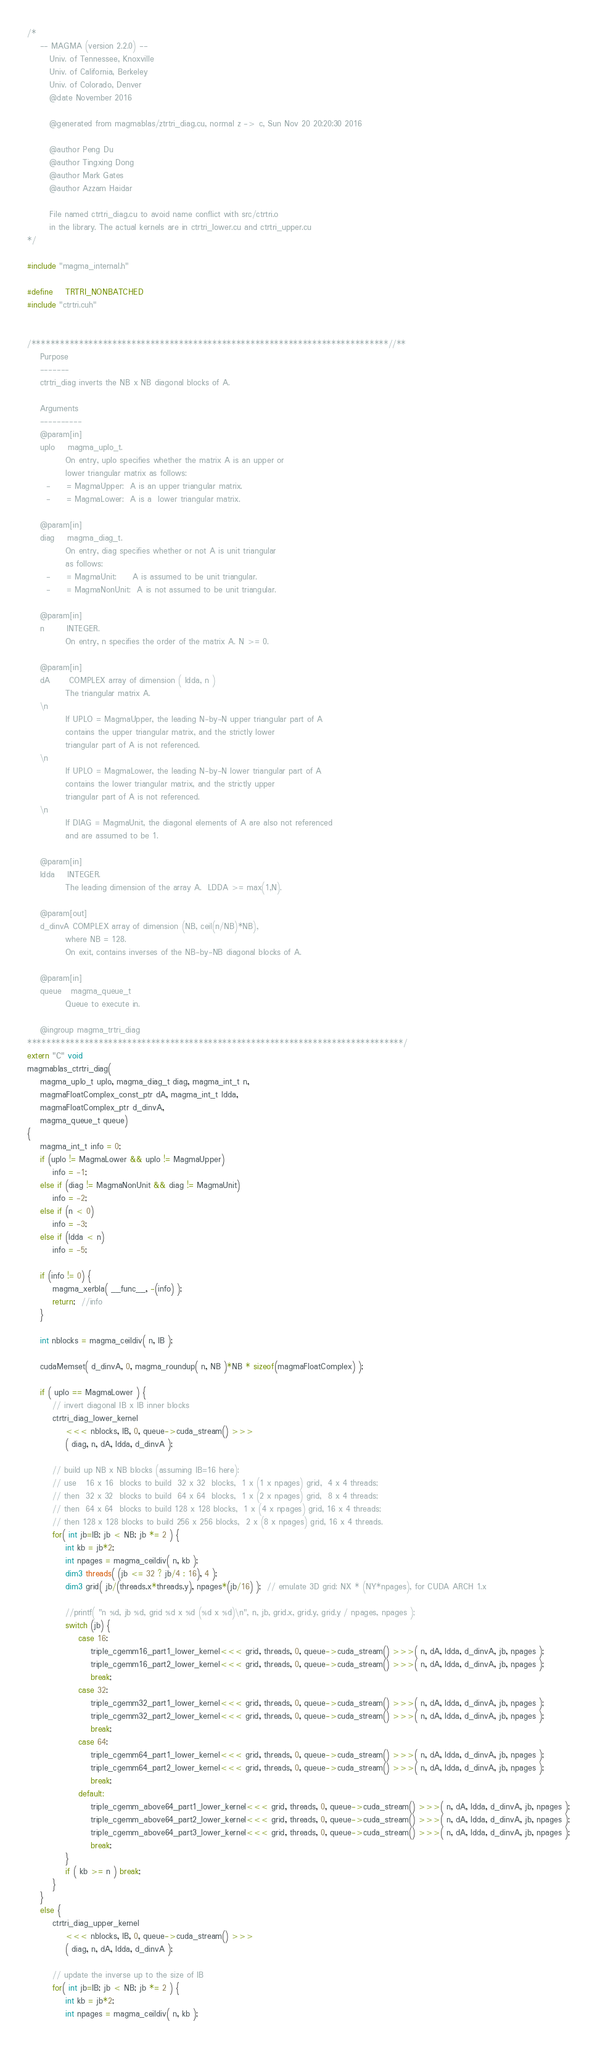Convert code to text. <code><loc_0><loc_0><loc_500><loc_500><_Cuda_>/*
    -- MAGMA (version 2.2.0) --
       Univ. of Tennessee, Knoxville
       Univ. of California, Berkeley
       Univ. of Colorado, Denver
       @date November 2016

       @generated from magmablas/ztrtri_diag.cu, normal z -> c, Sun Nov 20 20:20:30 2016

       @author Peng Du
       @author Tingxing Dong
       @author Mark Gates
       @author Azzam Haidar
       
       File named ctrtri_diag.cu to avoid name conflict with src/ctrtri.o
       in the library. The actual kernels are in ctrtri_lower.cu and ctrtri_upper.cu
*/

#include "magma_internal.h"

#define    TRTRI_NONBATCHED
#include "ctrtri.cuh"


/***************************************************************************//**
    Purpose
    -------
    ctrtri_diag inverts the NB x NB diagonal blocks of A.

    Arguments
    ----------
    @param[in]
    uplo    magma_uplo_t.
            On entry, uplo specifies whether the matrix A is an upper or
            lower triangular matrix as follows:
      -     = MagmaUpper:  A is an upper triangular matrix.
      -     = MagmaLower:  A is a  lower triangular matrix.

    @param[in]
    diag    magma_diag_t.
            On entry, diag specifies whether or not A is unit triangular
            as follows:
      -     = MagmaUnit:     A is assumed to be unit triangular.
      -     = MagmaNonUnit:  A is not assumed to be unit triangular.

    @param[in]
    n       INTEGER.
            On entry, n specifies the order of the matrix A. N >= 0.

    @param[in]
    dA      COMPLEX array of dimension ( ldda, n )
            The triangular matrix A.
    \n
            If UPLO = MagmaUpper, the leading N-by-N upper triangular part of A
            contains the upper triangular matrix, and the strictly lower
            triangular part of A is not referenced.
    \n
            If UPLO = MagmaLower, the leading N-by-N lower triangular part of A
            contains the lower triangular matrix, and the strictly upper
            triangular part of A is not referenced.
    \n
            If DIAG = MagmaUnit, the diagonal elements of A are also not referenced
            and are assumed to be 1.

    @param[in]
    ldda    INTEGER.
            The leading dimension of the array A.  LDDA >= max(1,N).

    @param[out]
    d_dinvA COMPLEX array of dimension (NB, ceil(n/NB)*NB),
            where NB = 128.
            On exit, contains inverses of the NB-by-NB diagonal blocks of A.

    @param[in]
    queue   magma_queue_t
            Queue to execute in.

    @ingroup magma_trtri_diag
*******************************************************************************/
extern "C" void
magmablas_ctrtri_diag(
    magma_uplo_t uplo, magma_diag_t diag, magma_int_t n,
    magmaFloatComplex_const_ptr dA, magma_int_t ldda,
    magmaFloatComplex_ptr d_dinvA,
    magma_queue_t queue)
{
    magma_int_t info = 0;
    if (uplo != MagmaLower && uplo != MagmaUpper)
        info = -1;
    else if (diag != MagmaNonUnit && diag != MagmaUnit)
        info = -2;
    else if (n < 0)
        info = -3;
    else if (ldda < n)
        info = -5;

    if (info != 0) {
        magma_xerbla( __func__, -(info) );
        return;  //info
    }
    
    int nblocks = magma_ceildiv( n, IB );

    cudaMemset( d_dinvA, 0, magma_roundup( n, NB )*NB * sizeof(magmaFloatComplex) );
    
    if ( uplo == MagmaLower ) {
        // invert diagonal IB x IB inner blocks
        ctrtri_diag_lower_kernel
            <<< nblocks, IB, 0, queue->cuda_stream() >>>
            ( diag, n, dA, ldda, d_dinvA );

        // build up NB x NB blocks (assuming IB=16 here):
        // use   16 x 16  blocks to build  32 x 32  blocks,  1 x (1 x npages) grid,  4 x 4 threads;
        // then  32 x 32  blocks to build  64 x 64  blocks,  1 x (2 x npages) grid,  8 x 4 threads;
        // then  64 x 64  blocks to build 128 x 128 blocks,  1 x (4 x npages) grid, 16 x 4 threads;
        // then 128 x 128 blocks to build 256 x 256 blocks,  2 x (8 x npages) grid, 16 x 4 threads.
        for( int jb=IB; jb < NB; jb *= 2 ) {
            int kb = jb*2;
            int npages = magma_ceildiv( n, kb );
            dim3 threads( (jb <= 32 ? jb/4 : 16), 4 );
            dim3 grid( jb/(threads.x*threads.y), npages*(jb/16) );  // emulate 3D grid: NX * (NY*npages), for CUDA ARCH 1.x
            
            //printf( "n %d, jb %d, grid %d x %d (%d x %d)\n", n, jb, grid.x, grid.y, grid.y / npages, npages );
            switch (jb) {
                case 16:
                    triple_cgemm16_part1_lower_kernel<<< grid, threads, 0, queue->cuda_stream() >>>( n, dA, ldda, d_dinvA, jb, npages );
                    triple_cgemm16_part2_lower_kernel<<< grid, threads, 0, queue->cuda_stream() >>>( n, dA, ldda, d_dinvA, jb, npages );
                    break;
                case 32:
                    triple_cgemm32_part1_lower_kernel<<< grid, threads, 0, queue->cuda_stream() >>>( n, dA, ldda, d_dinvA, jb, npages );
                    triple_cgemm32_part2_lower_kernel<<< grid, threads, 0, queue->cuda_stream() >>>( n, dA, ldda, d_dinvA, jb, npages );
                    break;
                case 64:
                    triple_cgemm64_part1_lower_kernel<<< grid, threads, 0, queue->cuda_stream() >>>( n, dA, ldda, d_dinvA, jb, npages );
                    triple_cgemm64_part2_lower_kernel<<< grid, threads, 0, queue->cuda_stream() >>>( n, dA, ldda, d_dinvA, jb, npages );
                    break;
                default:
                    triple_cgemm_above64_part1_lower_kernel<<< grid, threads, 0, queue->cuda_stream() >>>( n, dA, ldda, d_dinvA, jb, npages );
                    triple_cgemm_above64_part2_lower_kernel<<< grid, threads, 0, queue->cuda_stream() >>>( n, dA, ldda, d_dinvA, jb, npages );
                    triple_cgemm_above64_part3_lower_kernel<<< grid, threads, 0, queue->cuda_stream() >>>( n, dA, ldda, d_dinvA, jb, npages );
                    break;
            }
            if ( kb >= n ) break;
        }
    }
    else {
        ctrtri_diag_upper_kernel
            <<< nblocks, IB, 0, queue->cuda_stream() >>>
            ( diag, n, dA, ldda, d_dinvA );

        // update the inverse up to the size of IB
        for( int jb=IB; jb < NB; jb *= 2 ) {
            int kb = jb*2;
            int npages = magma_ceildiv( n, kb );</code> 